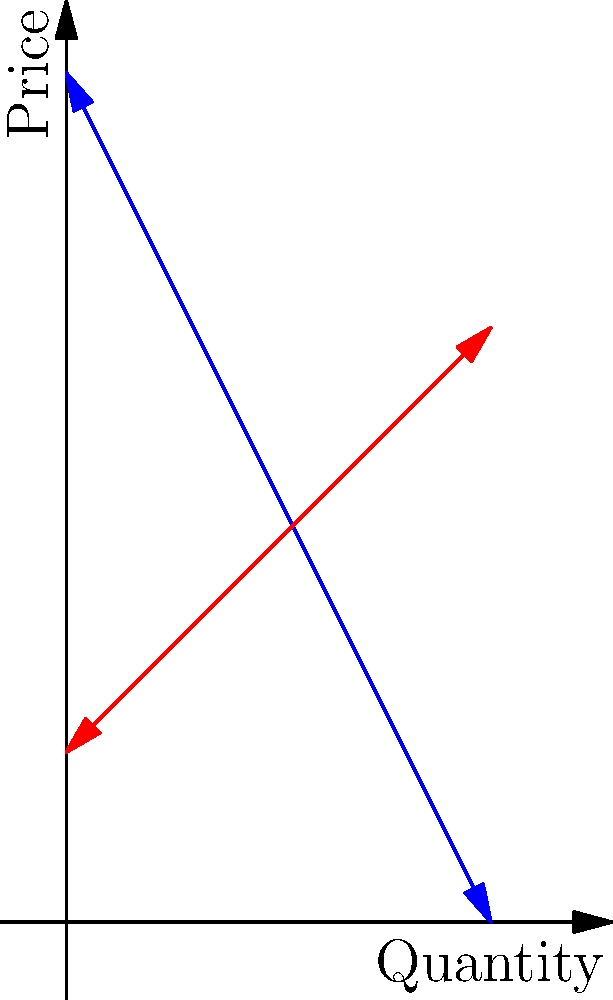In a remote Balkan tribal community, the demand for traditional handwoven rugs is given by the function $P = 100 - 2Q$, where $P$ is the price in local currency and $Q$ is the quantity produced. The supply function is $P = 20 + Q$. As a tribal leader, you need to determine the optimal quantity and price for these rugs to maximize the total economic benefit for your community. What is the equilibrium quantity of rugs that should be produced? To find the equilibrium quantity, we need to follow these steps:

1) At equilibrium, supply equals demand. So we set the two equations equal to each other:
   
   $100 - 2Q = 20 + Q$

2) Solve this equation for Q:
   
   $100 - 2Q = 20 + Q$
   $80 = 3Q$
   $Q = \frac{80}{3} = 26.67$

3) The equilibrium quantity is where the supply and demand curves intersect. This occurs at $Q = 26.67$ rugs.

4) We can verify this by plugging this Q value back into either the supply or demand equation to find the equilibrium price:

   $P = 100 - 2(26.67) = 46.67$
   
   or
   
   $P = 20 + 26.67 = 46.67$

So, at equilibrium, 26.67 rugs should be produced at a price of 46.67 in local currency.

This quantity maximizes the total economic benefit because at this point, the marginal benefit to consumers (represented by the demand curve) equals the marginal cost to producers (represented by the supply curve).
Answer: 26.67 rugs 